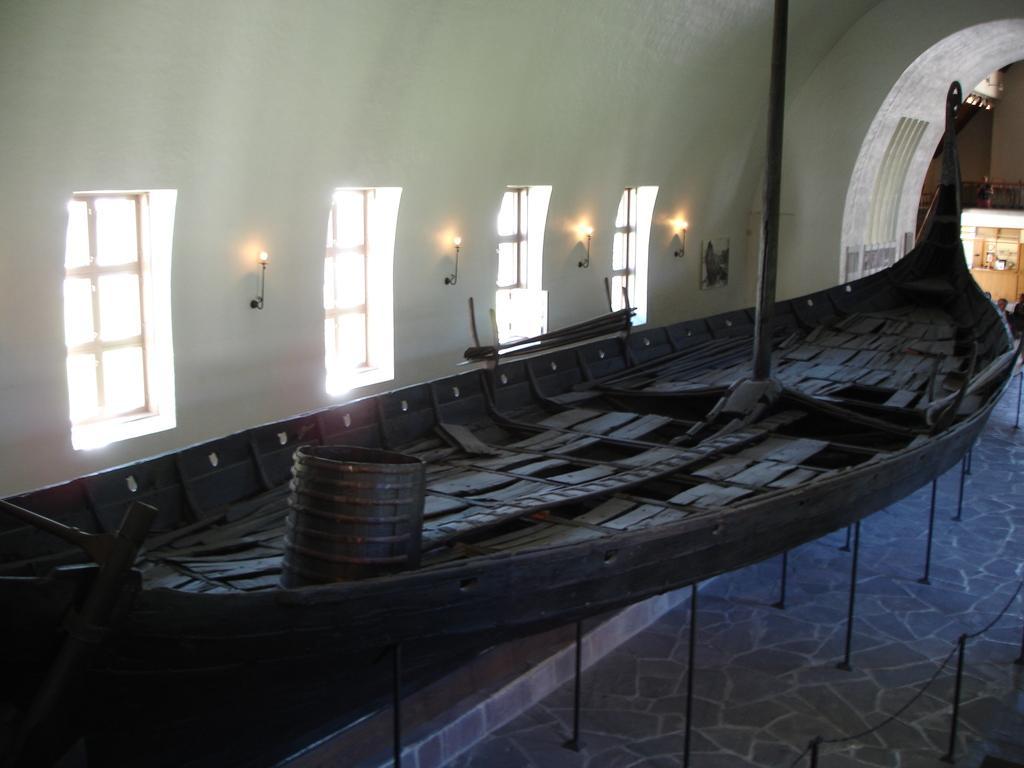How would you summarize this image in a sentence or two? In this image, we can see a boat on stand. There are windows and lights in the middle of the image. There is a barricade stand in the bottom right of the image. 